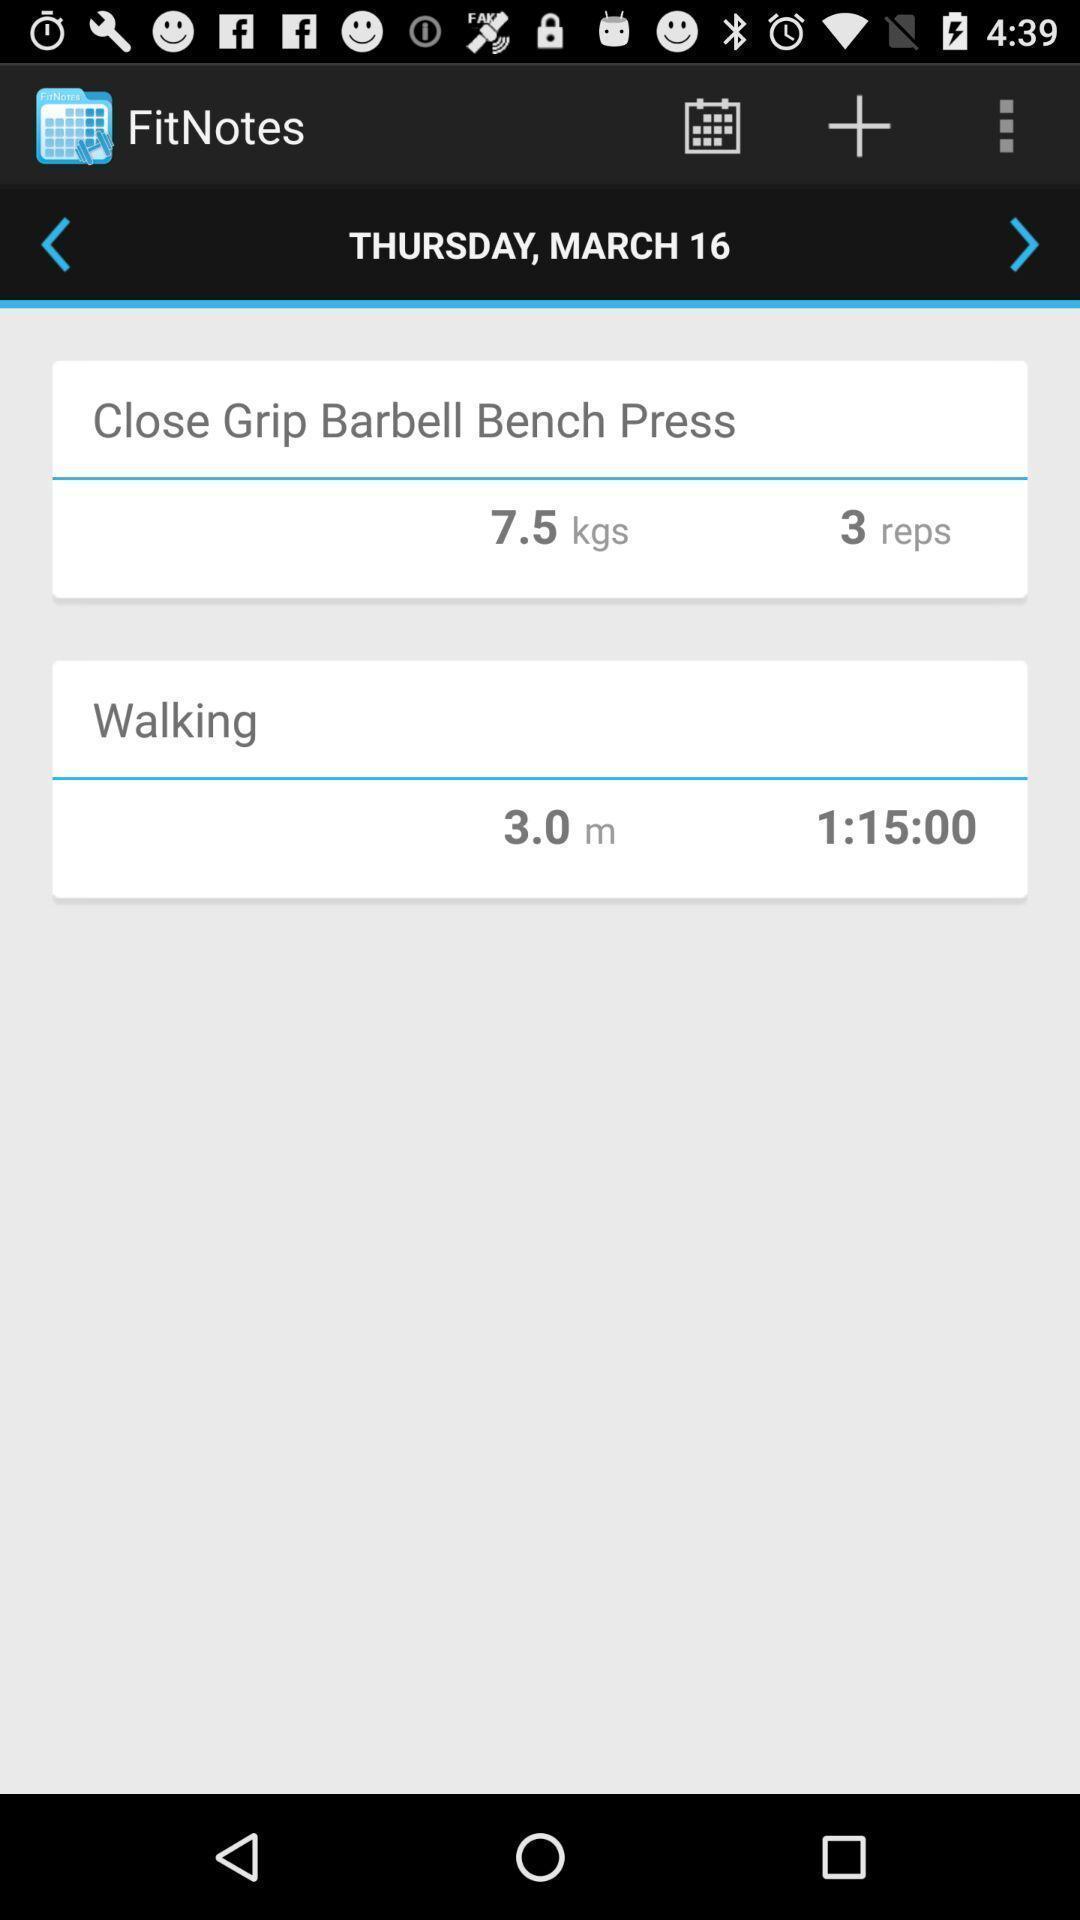Give me a summary of this screen capture. Screen shows the tracker in a workout application. 